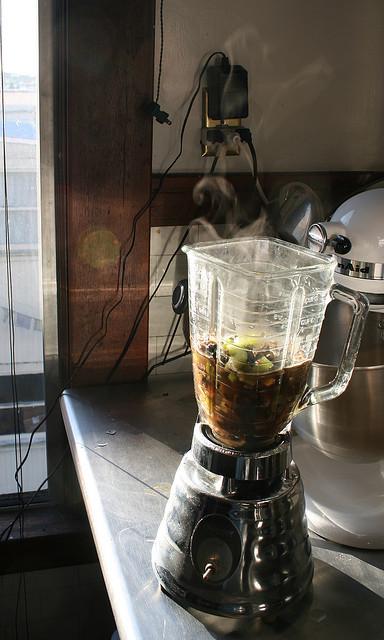Is the window behind the drink locked or unlocked?
Short answer required. Locked. Is the blender filled with a substance?
Keep it brief. Yes. Do the long shadows suggest it is well past morning?
Concise answer only. Yes. Is someone making a smoothie?
Answer briefly. Yes. 